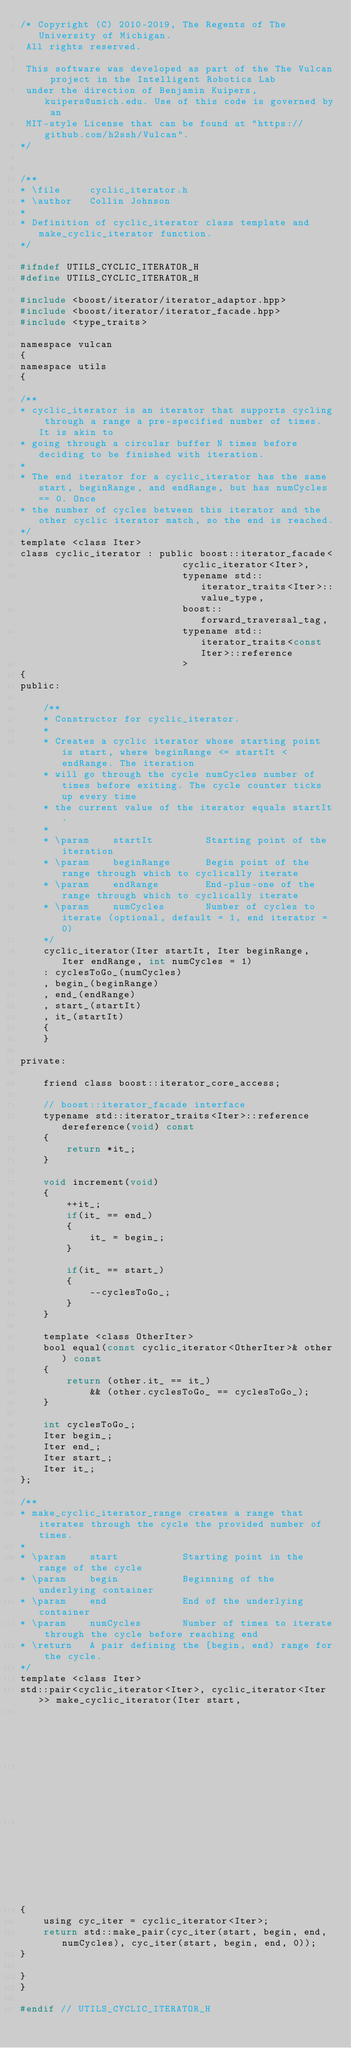Convert code to text. <code><loc_0><loc_0><loc_500><loc_500><_C_>/* Copyright (C) 2010-2019, The Regents of The University of Michigan.
 All rights reserved.

 This software was developed as part of the The Vulcan project in the Intelligent Robotics Lab
 under the direction of Benjamin Kuipers, kuipers@umich.edu. Use of this code is governed by an
 MIT-style License that can be found at "https://github.com/h2ssh/Vulcan".
*/


/**
* \file     cyclic_iterator.h
* \author   Collin Johnson
* 
* Definition of cyclic_iterator class template and make_cyclic_iterator function.
*/

#ifndef UTILS_CYCLIC_ITERATOR_H
#define UTILS_CYCLIC_ITERATOR_H

#include <boost/iterator/iterator_adaptor.hpp>
#include <boost/iterator/iterator_facade.hpp>
#include <type_traits>

namespace vulcan
{
namespace utils
{

/**
* cyclic_iterator is an iterator that supports cycling through a range a pre-specified number of times. It is akin to 
* going through a circular buffer N times before deciding to be finished with iteration.
* 
* The end iterator for a cyclic_iterator has the same start, beginRange, and endRange, but has numCycles == 0. Once
* the number of cycles between this iterator and the other cyclic iterator match, so the end is reached.
*/
template <class Iter>
class cyclic_iterator : public boost::iterator_facade<
                            cyclic_iterator<Iter>,
                            typename std::iterator_traits<Iter>::value_type,
                            boost::forward_traversal_tag,
                            typename std::iterator_traits<const Iter>::reference
                            >
{
public:
    
    /**
    * Constructor for cyclic_iterator.
    * 
    * Creates a cyclic iterator whose starting point is start, where beginRange <= startIt < endRange. The iteration
    * will go through the cycle numCycles number of times before exiting. The cycle counter ticks up every time 
    * the current value of the iterator equals startIt.
    * 
    * \param    startIt         Starting point of the iteration
    * \param    beginRange      Begin point of the range through which to cyclically iterate
    * \param    endRange        End-plus-one of the range through which to cyclically iterate
    * \param    numCycles       Number of cycles to iterate (optional, default = 1, end iterator = 0)
    */
    cyclic_iterator(Iter startIt, Iter beginRange, Iter endRange, int numCycles = 1)
    : cyclesToGo_(numCycles)
    , begin_(beginRange)
    , end_(endRange)
    , start_(startIt)
    , it_(startIt)
    {
    }
    
private:
    
    friend class boost::iterator_core_access;
    
    // boost::iterator_facade interface
    typename std::iterator_traits<Iter>::reference dereference(void) const
    {
        return *it_;
    }
    
    void increment(void)
    {
        ++it_;
        if(it_ == end_)
        {
            it_ = begin_;
        }
        
        if(it_ == start_)
        {
            --cyclesToGo_;
        }
    }
    
    template <class OtherIter>
    bool equal(const cyclic_iterator<OtherIter>& other) const 
    {
        return (other.it_ == it_)
            && (other.cyclesToGo_ == cyclesToGo_);
    }
    
    int cyclesToGo_;
    Iter begin_;
    Iter end_;
    Iter start_;
    Iter it_;
};

/**
* make_cyclic_iterator_range creates a range that iterates through the cycle the provided number of times.
* 
* \param    start           Starting point in the range of the cycle
* \param    begin           Beginning of the underlying container
* \param    end             End of the underlying container
* \param    numCycles       Number of times to iterate through the cycle before reaching end
* \return   A pair defining the [begin, end) range for the cycle.
*/
template <class Iter>
std::pair<cyclic_iterator<Iter>, cyclic_iterator<Iter>> make_cyclic_iterator(Iter start, 
                                                                             Iter begin, 
                                                                             Iter end, 
                                                                             int numCycles = 1)
{
    using cyc_iter = cyclic_iterator<Iter>;
    return std::make_pair(cyc_iter(start, begin, end, numCycles), cyc_iter(start, begin, end, 0));
}

}
}

#endif // UTILS_CYCLIC_ITERATOR_H
</code> 